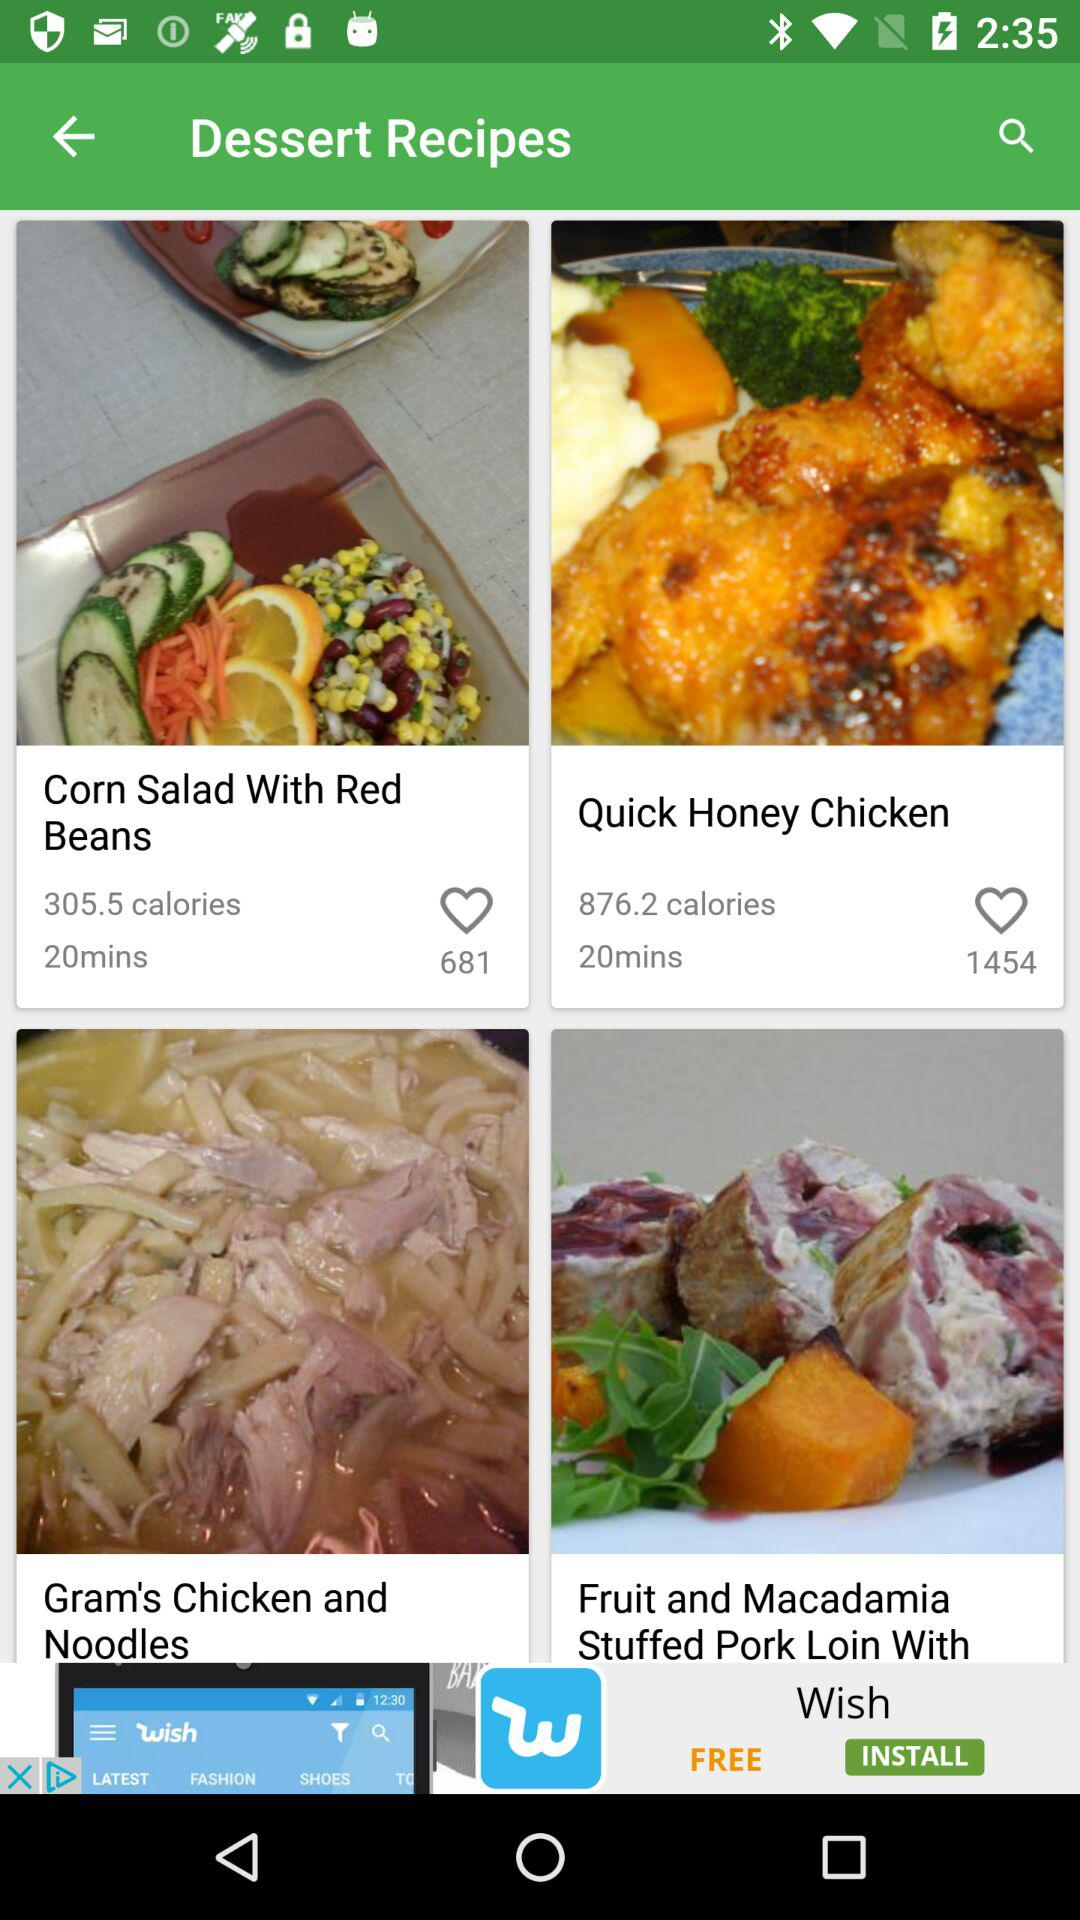How many likes are there of "Corn Salad With Red Beans"? There are 681 likes of "Corn Salad With Red Beans". 